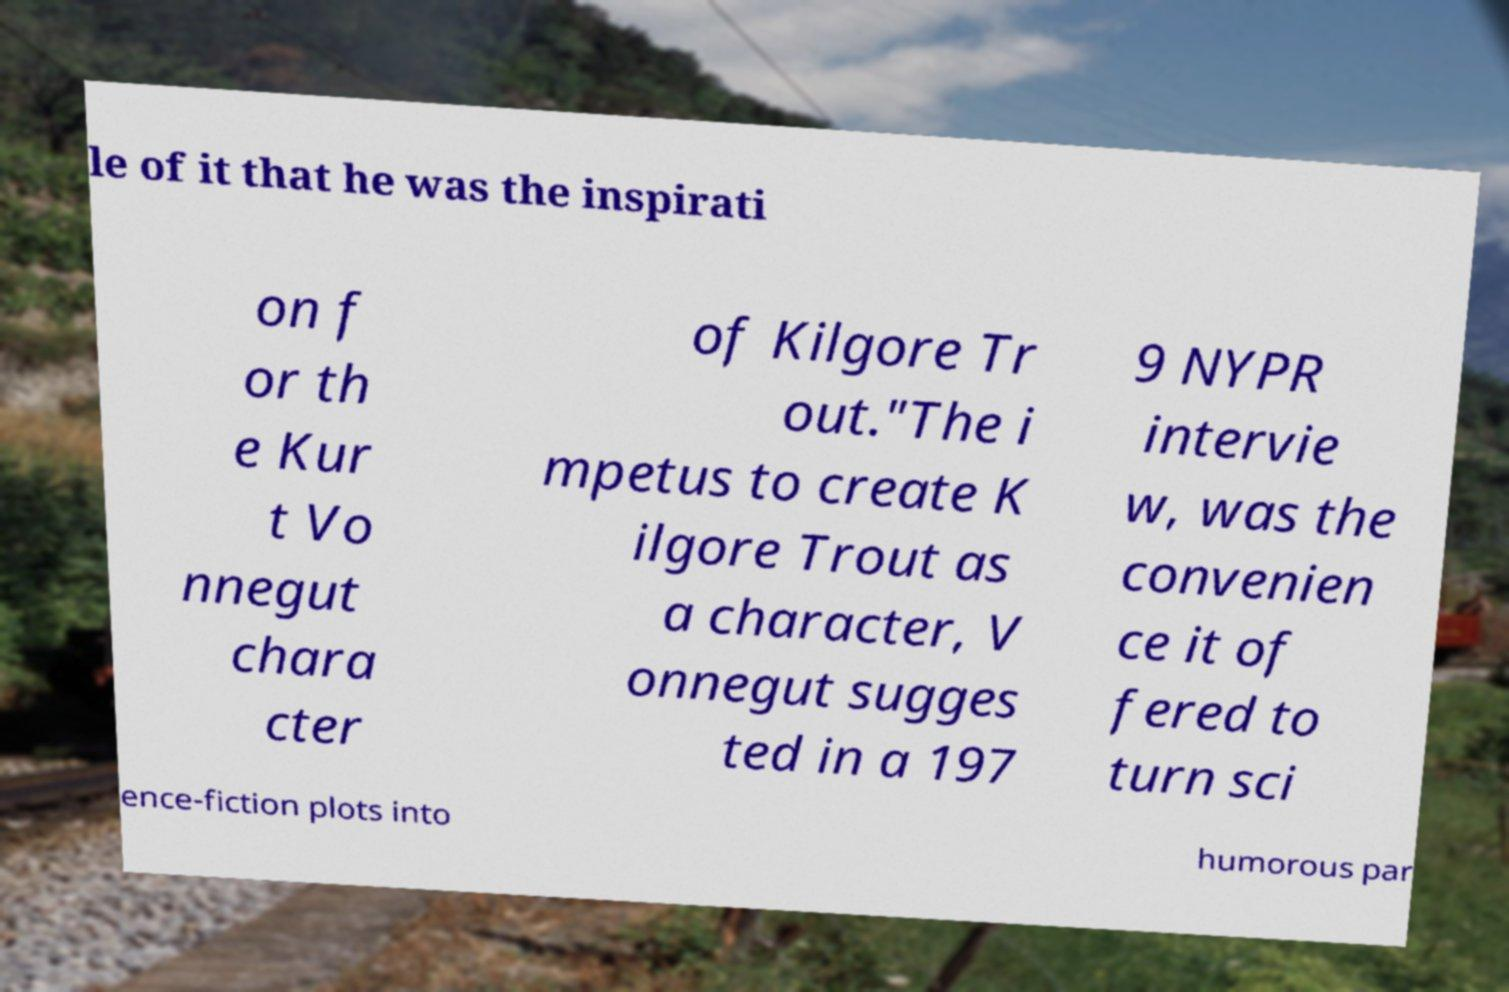Could you extract and type out the text from this image? le of it that he was the inspirati on f or th e Kur t Vo nnegut chara cter of Kilgore Tr out."The i mpetus to create K ilgore Trout as a character, V onnegut sugges ted in a 197 9 NYPR intervie w, was the convenien ce it of fered to turn sci ence-fiction plots into humorous par 